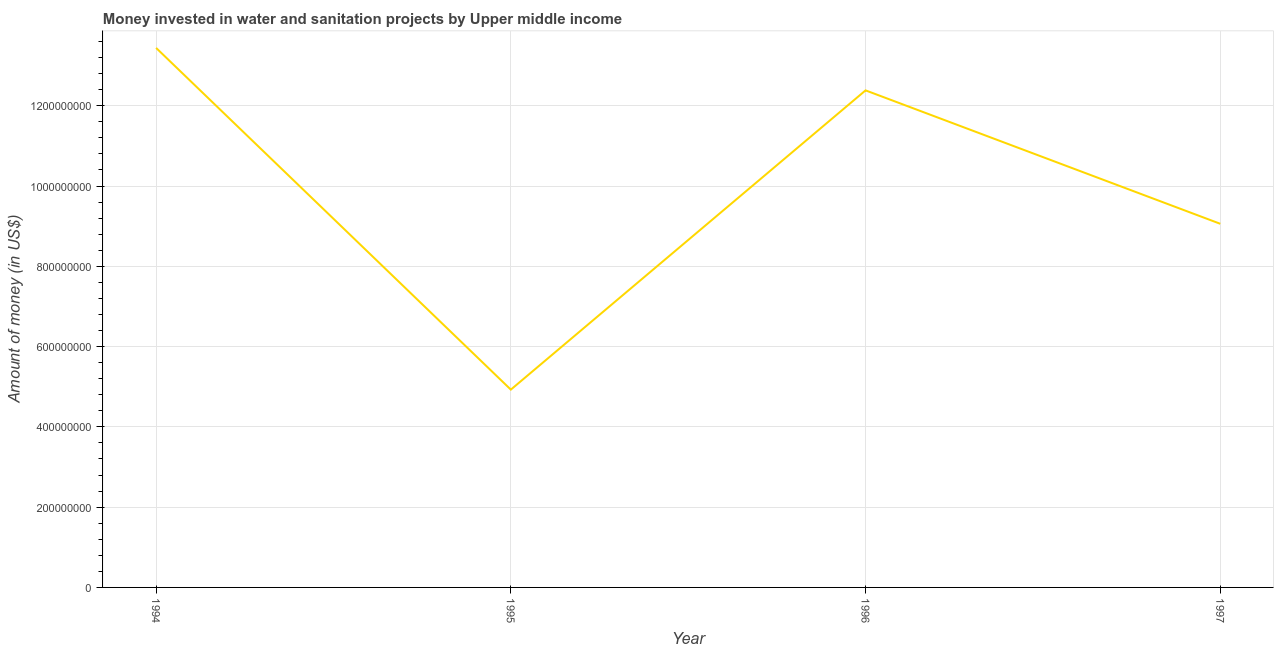What is the investment in 1997?
Ensure brevity in your answer.  9.06e+08. Across all years, what is the maximum investment?
Offer a terse response. 1.34e+09. Across all years, what is the minimum investment?
Provide a short and direct response. 4.93e+08. In which year was the investment minimum?
Your answer should be very brief. 1995. What is the sum of the investment?
Your answer should be compact. 3.98e+09. What is the difference between the investment in 1995 and 1996?
Your answer should be very brief. -7.46e+08. What is the average investment per year?
Your response must be concise. 9.95e+08. What is the median investment?
Ensure brevity in your answer.  1.07e+09. What is the ratio of the investment in 1994 to that in 1995?
Give a very brief answer. 2.73. Is the investment in 1995 less than that in 1996?
Provide a short and direct response. Yes. What is the difference between the highest and the second highest investment?
Your answer should be very brief. 1.06e+08. Is the sum of the investment in 1996 and 1997 greater than the maximum investment across all years?
Your response must be concise. Yes. What is the difference between the highest and the lowest investment?
Your answer should be compact. 8.51e+08. In how many years, is the investment greater than the average investment taken over all years?
Provide a short and direct response. 2. Does the investment monotonically increase over the years?
Give a very brief answer. No. How many lines are there?
Keep it short and to the point. 1. How many years are there in the graph?
Make the answer very short. 4. What is the difference between two consecutive major ticks on the Y-axis?
Your answer should be very brief. 2.00e+08. Are the values on the major ticks of Y-axis written in scientific E-notation?
Provide a succinct answer. No. Does the graph contain grids?
Keep it short and to the point. Yes. What is the title of the graph?
Make the answer very short. Money invested in water and sanitation projects by Upper middle income. What is the label or title of the X-axis?
Keep it short and to the point. Year. What is the label or title of the Y-axis?
Provide a succinct answer. Amount of money (in US$). What is the Amount of money (in US$) in 1994?
Provide a short and direct response. 1.34e+09. What is the Amount of money (in US$) of 1995?
Keep it short and to the point. 4.93e+08. What is the Amount of money (in US$) in 1996?
Your answer should be compact. 1.24e+09. What is the Amount of money (in US$) of 1997?
Give a very brief answer. 9.06e+08. What is the difference between the Amount of money (in US$) in 1994 and 1995?
Offer a very short reply. 8.51e+08. What is the difference between the Amount of money (in US$) in 1994 and 1996?
Provide a succinct answer. 1.06e+08. What is the difference between the Amount of money (in US$) in 1994 and 1997?
Ensure brevity in your answer.  4.38e+08. What is the difference between the Amount of money (in US$) in 1995 and 1996?
Offer a terse response. -7.46e+08. What is the difference between the Amount of money (in US$) in 1995 and 1997?
Ensure brevity in your answer.  -4.13e+08. What is the difference between the Amount of money (in US$) in 1996 and 1997?
Ensure brevity in your answer.  3.32e+08. What is the ratio of the Amount of money (in US$) in 1994 to that in 1995?
Offer a very short reply. 2.73. What is the ratio of the Amount of money (in US$) in 1994 to that in 1996?
Keep it short and to the point. 1.08. What is the ratio of the Amount of money (in US$) in 1994 to that in 1997?
Keep it short and to the point. 1.48. What is the ratio of the Amount of money (in US$) in 1995 to that in 1996?
Provide a succinct answer. 0.4. What is the ratio of the Amount of money (in US$) in 1995 to that in 1997?
Your answer should be compact. 0.54. What is the ratio of the Amount of money (in US$) in 1996 to that in 1997?
Give a very brief answer. 1.37. 